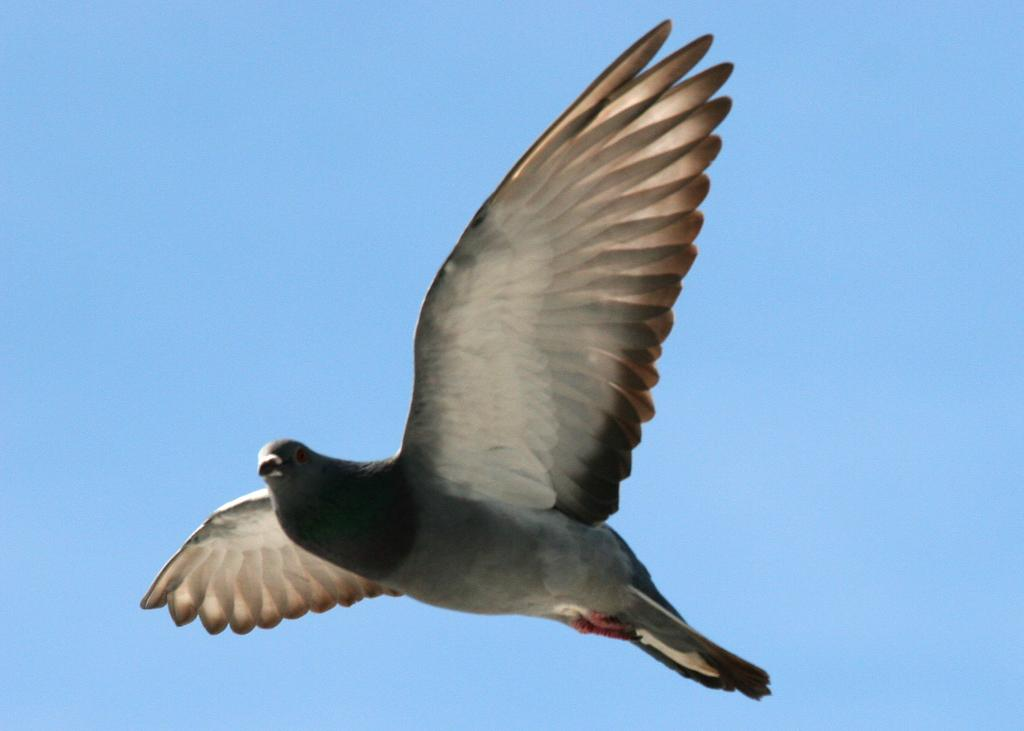What is the main subject of the image? The main subject of the image is a bird flying in the center of the image. What can be seen in the background of the image? The sky is visible in the background of the image. What type of mitten is the bird wearing in the image? There is no mitten present in the image, as birds do not wear mittens. What drug is the bird using in the image? There is no drug present in the image, as the image only features a bird flying in the sky. 